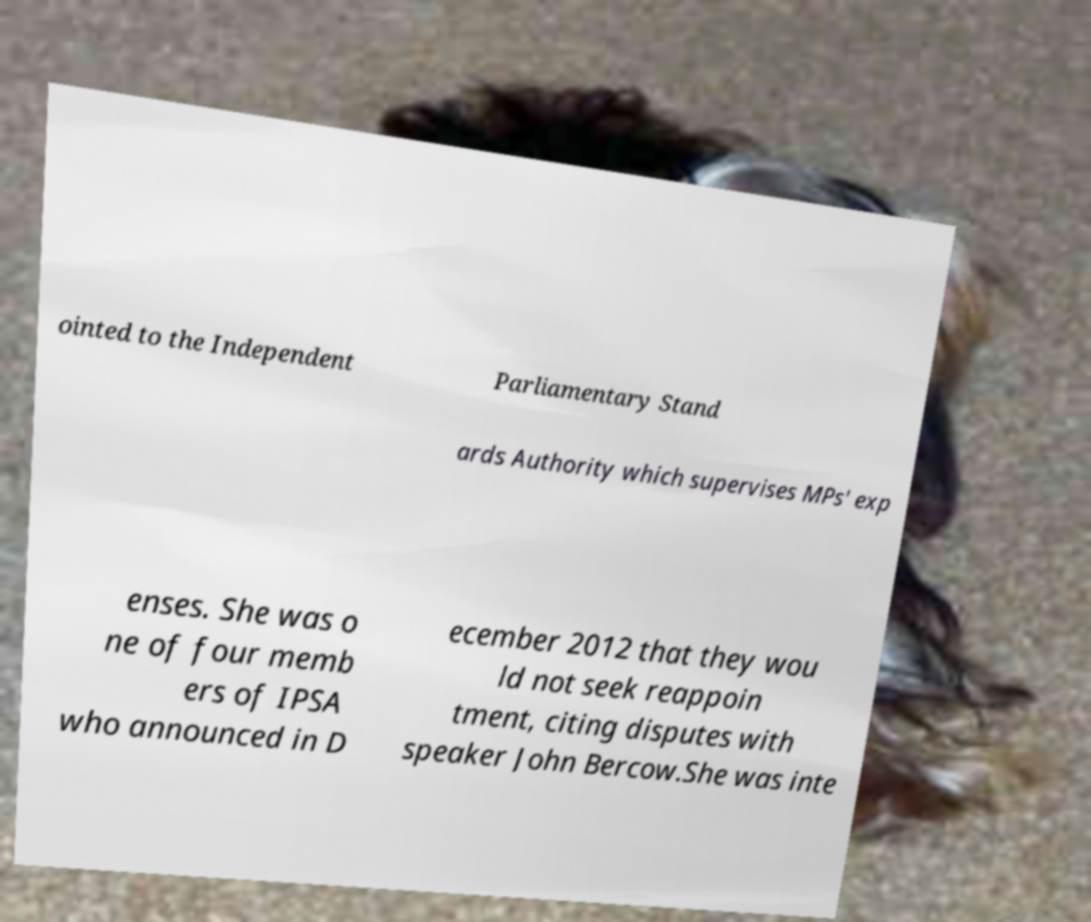Could you extract and type out the text from this image? ointed to the Independent Parliamentary Stand ards Authority which supervises MPs' exp enses. She was o ne of four memb ers of IPSA who announced in D ecember 2012 that they wou ld not seek reappoin tment, citing disputes with speaker John Bercow.She was inte 